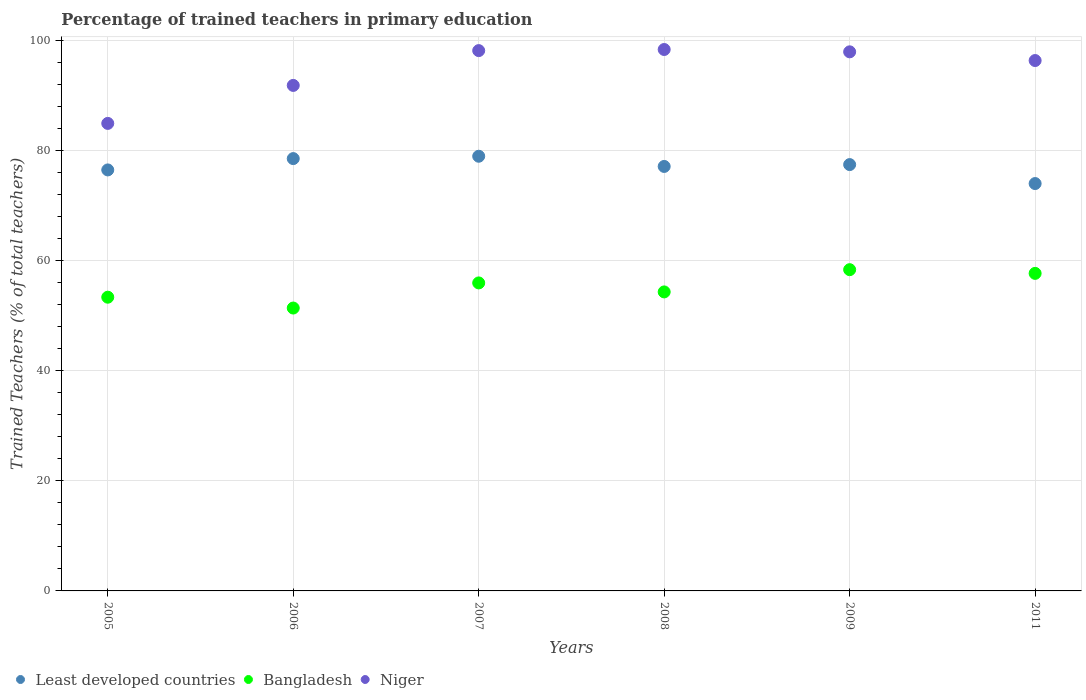Is the number of dotlines equal to the number of legend labels?
Give a very brief answer. Yes. What is the percentage of trained teachers in Bangladesh in 2006?
Provide a succinct answer. 51.43. Across all years, what is the maximum percentage of trained teachers in Bangladesh?
Your answer should be very brief. 58.41. Across all years, what is the minimum percentage of trained teachers in Least developed countries?
Provide a short and direct response. 74.06. In which year was the percentage of trained teachers in Least developed countries minimum?
Give a very brief answer. 2011. What is the total percentage of trained teachers in Bangladesh in the graph?
Your response must be concise. 331.34. What is the difference between the percentage of trained teachers in Niger in 2007 and that in 2009?
Provide a succinct answer. 0.22. What is the difference between the percentage of trained teachers in Bangladesh in 2005 and the percentage of trained teachers in Niger in 2009?
Your response must be concise. -44.61. What is the average percentage of trained teachers in Niger per year?
Your answer should be compact. 94.67. In the year 2006, what is the difference between the percentage of trained teachers in Niger and percentage of trained teachers in Bangladesh?
Provide a short and direct response. 40.48. In how many years, is the percentage of trained teachers in Niger greater than 68 %?
Give a very brief answer. 6. What is the ratio of the percentage of trained teachers in Niger in 2005 to that in 2006?
Give a very brief answer. 0.92. Is the percentage of trained teachers in Least developed countries in 2006 less than that in 2007?
Offer a terse response. Yes. Is the difference between the percentage of trained teachers in Niger in 2009 and 2011 greater than the difference between the percentage of trained teachers in Bangladesh in 2009 and 2011?
Provide a succinct answer. Yes. What is the difference between the highest and the second highest percentage of trained teachers in Niger?
Give a very brief answer. 0.2. What is the difference between the highest and the lowest percentage of trained teachers in Bangladesh?
Provide a short and direct response. 6.98. In how many years, is the percentage of trained teachers in Bangladesh greater than the average percentage of trained teachers in Bangladesh taken over all years?
Ensure brevity in your answer.  3. Is the percentage of trained teachers in Niger strictly less than the percentage of trained teachers in Least developed countries over the years?
Your answer should be compact. No. Are the values on the major ticks of Y-axis written in scientific E-notation?
Give a very brief answer. No. Does the graph contain any zero values?
Your answer should be very brief. No. Where does the legend appear in the graph?
Ensure brevity in your answer.  Bottom left. What is the title of the graph?
Your answer should be very brief. Percentage of trained teachers in primary education. Does "Belarus" appear as one of the legend labels in the graph?
Provide a succinct answer. No. What is the label or title of the Y-axis?
Provide a short and direct response. Trained Teachers (% of total teachers). What is the Trained Teachers (% of total teachers) in Least developed countries in 2005?
Offer a terse response. 76.54. What is the Trained Teachers (% of total teachers) in Bangladesh in 2005?
Keep it short and to the point. 53.4. What is the Trained Teachers (% of total teachers) of Niger in 2005?
Give a very brief answer. 85. What is the Trained Teachers (% of total teachers) in Least developed countries in 2006?
Keep it short and to the point. 78.6. What is the Trained Teachers (% of total teachers) of Bangladesh in 2006?
Keep it short and to the point. 51.43. What is the Trained Teachers (% of total teachers) in Niger in 2006?
Ensure brevity in your answer.  91.91. What is the Trained Teachers (% of total teachers) in Least developed countries in 2007?
Ensure brevity in your answer.  79.03. What is the Trained Teachers (% of total teachers) in Bangladesh in 2007?
Give a very brief answer. 56. What is the Trained Teachers (% of total teachers) in Niger in 2007?
Provide a succinct answer. 98.24. What is the Trained Teachers (% of total teachers) in Least developed countries in 2008?
Ensure brevity in your answer.  77.18. What is the Trained Teachers (% of total teachers) in Bangladesh in 2008?
Your answer should be very brief. 54.36. What is the Trained Teachers (% of total teachers) of Niger in 2008?
Ensure brevity in your answer.  98.44. What is the Trained Teachers (% of total teachers) of Least developed countries in 2009?
Offer a very short reply. 77.51. What is the Trained Teachers (% of total teachers) of Bangladesh in 2009?
Make the answer very short. 58.41. What is the Trained Teachers (% of total teachers) of Niger in 2009?
Give a very brief answer. 98.01. What is the Trained Teachers (% of total teachers) in Least developed countries in 2011?
Your answer should be very brief. 74.06. What is the Trained Teachers (% of total teachers) in Bangladesh in 2011?
Provide a short and direct response. 57.73. What is the Trained Teachers (% of total teachers) of Niger in 2011?
Your answer should be very brief. 96.43. Across all years, what is the maximum Trained Teachers (% of total teachers) of Least developed countries?
Your answer should be very brief. 79.03. Across all years, what is the maximum Trained Teachers (% of total teachers) in Bangladesh?
Offer a terse response. 58.41. Across all years, what is the maximum Trained Teachers (% of total teachers) in Niger?
Keep it short and to the point. 98.44. Across all years, what is the minimum Trained Teachers (% of total teachers) of Least developed countries?
Give a very brief answer. 74.06. Across all years, what is the minimum Trained Teachers (% of total teachers) in Bangladesh?
Your response must be concise. 51.43. Across all years, what is the minimum Trained Teachers (% of total teachers) in Niger?
Give a very brief answer. 85. What is the total Trained Teachers (% of total teachers) of Least developed countries in the graph?
Give a very brief answer. 462.93. What is the total Trained Teachers (% of total teachers) in Bangladesh in the graph?
Give a very brief answer. 331.34. What is the total Trained Teachers (% of total teachers) of Niger in the graph?
Offer a very short reply. 568.03. What is the difference between the Trained Teachers (% of total teachers) of Least developed countries in 2005 and that in 2006?
Offer a terse response. -2.06. What is the difference between the Trained Teachers (% of total teachers) in Bangladesh in 2005 and that in 2006?
Ensure brevity in your answer.  1.97. What is the difference between the Trained Teachers (% of total teachers) in Niger in 2005 and that in 2006?
Offer a very short reply. -6.91. What is the difference between the Trained Teachers (% of total teachers) in Least developed countries in 2005 and that in 2007?
Your response must be concise. -2.49. What is the difference between the Trained Teachers (% of total teachers) of Bangladesh in 2005 and that in 2007?
Ensure brevity in your answer.  -2.6. What is the difference between the Trained Teachers (% of total teachers) of Niger in 2005 and that in 2007?
Make the answer very short. -13.24. What is the difference between the Trained Teachers (% of total teachers) in Least developed countries in 2005 and that in 2008?
Ensure brevity in your answer.  -0.63. What is the difference between the Trained Teachers (% of total teachers) of Bangladesh in 2005 and that in 2008?
Give a very brief answer. -0.96. What is the difference between the Trained Teachers (% of total teachers) of Niger in 2005 and that in 2008?
Provide a short and direct response. -13.44. What is the difference between the Trained Teachers (% of total teachers) in Least developed countries in 2005 and that in 2009?
Your answer should be compact. -0.97. What is the difference between the Trained Teachers (% of total teachers) in Bangladesh in 2005 and that in 2009?
Offer a terse response. -5.01. What is the difference between the Trained Teachers (% of total teachers) in Niger in 2005 and that in 2009?
Your answer should be very brief. -13.01. What is the difference between the Trained Teachers (% of total teachers) in Least developed countries in 2005 and that in 2011?
Ensure brevity in your answer.  2.48. What is the difference between the Trained Teachers (% of total teachers) in Bangladesh in 2005 and that in 2011?
Your response must be concise. -4.33. What is the difference between the Trained Teachers (% of total teachers) of Niger in 2005 and that in 2011?
Offer a terse response. -11.43. What is the difference between the Trained Teachers (% of total teachers) in Least developed countries in 2006 and that in 2007?
Offer a terse response. -0.43. What is the difference between the Trained Teachers (% of total teachers) of Bangladesh in 2006 and that in 2007?
Provide a short and direct response. -4.57. What is the difference between the Trained Teachers (% of total teachers) in Niger in 2006 and that in 2007?
Offer a terse response. -6.33. What is the difference between the Trained Teachers (% of total teachers) in Least developed countries in 2006 and that in 2008?
Make the answer very short. 1.43. What is the difference between the Trained Teachers (% of total teachers) of Bangladesh in 2006 and that in 2008?
Ensure brevity in your answer.  -2.93. What is the difference between the Trained Teachers (% of total teachers) in Niger in 2006 and that in 2008?
Make the answer very short. -6.53. What is the difference between the Trained Teachers (% of total teachers) of Least developed countries in 2006 and that in 2009?
Offer a very short reply. 1.09. What is the difference between the Trained Teachers (% of total teachers) in Bangladesh in 2006 and that in 2009?
Provide a succinct answer. -6.98. What is the difference between the Trained Teachers (% of total teachers) of Niger in 2006 and that in 2009?
Give a very brief answer. -6.11. What is the difference between the Trained Teachers (% of total teachers) in Least developed countries in 2006 and that in 2011?
Ensure brevity in your answer.  4.54. What is the difference between the Trained Teachers (% of total teachers) of Bangladesh in 2006 and that in 2011?
Provide a succinct answer. -6.3. What is the difference between the Trained Teachers (% of total teachers) of Niger in 2006 and that in 2011?
Offer a terse response. -4.52. What is the difference between the Trained Teachers (% of total teachers) in Least developed countries in 2007 and that in 2008?
Give a very brief answer. 1.85. What is the difference between the Trained Teachers (% of total teachers) of Bangladesh in 2007 and that in 2008?
Keep it short and to the point. 1.64. What is the difference between the Trained Teachers (% of total teachers) of Niger in 2007 and that in 2008?
Provide a short and direct response. -0.2. What is the difference between the Trained Teachers (% of total teachers) of Least developed countries in 2007 and that in 2009?
Give a very brief answer. 1.52. What is the difference between the Trained Teachers (% of total teachers) of Bangladesh in 2007 and that in 2009?
Make the answer very short. -2.41. What is the difference between the Trained Teachers (% of total teachers) of Niger in 2007 and that in 2009?
Your answer should be very brief. 0.22. What is the difference between the Trained Teachers (% of total teachers) of Least developed countries in 2007 and that in 2011?
Provide a short and direct response. 4.97. What is the difference between the Trained Teachers (% of total teachers) in Bangladesh in 2007 and that in 2011?
Offer a very short reply. -1.74. What is the difference between the Trained Teachers (% of total teachers) of Niger in 2007 and that in 2011?
Your response must be concise. 1.81. What is the difference between the Trained Teachers (% of total teachers) in Least developed countries in 2008 and that in 2009?
Provide a short and direct response. -0.34. What is the difference between the Trained Teachers (% of total teachers) in Bangladesh in 2008 and that in 2009?
Provide a short and direct response. -4.04. What is the difference between the Trained Teachers (% of total teachers) in Niger in 2008 and that in 2009?
Provide a short and direct response. 0.42. What is the difference between the Trained Teachers (% of total teachers) of Least developed countries in 2008 and that in 2011?
Ensure brevity in your answer.  3.11. What is the difference between the Trained Teachers (% of total teachers) of Bangladesh in 2008 and that in 2011?
Make the answer very short. -3.37. What is the difference between the Trained Teachers (% of total teachers) of Niger in 2008 and that in 2011?
Your answer should be compact. 2.01. What is the difference between the Trained Teachers (% of total teachers) in Least developed countries in 2009 and that in 2011?
Ensure brevity in your answer.  3.45. What is the difference between the Trained Teachers (% of total teachers) in Bangladesh in 2009 and that in 2011?
Your response must be concise. 0.67. What is the difference between the Trained Teachers (% of total teachers) in Niger in 2009 and that in 2011?
Provide a succinct answer. 1.58. What is the difference between the Trained Teachers (% of total teachers) of Least developed countries in 2005 and the Trained Teachers (% of total teachers) of Bangladesh in 2006?
Provide a succinct answer. 25.11. What is the difference between the Trained Teachers (% of total teachers) in Least developed countries in 2005 and the Trained Teachers (% of total teachers) in Niger in 2006?
Provide a short and direct response. -15.36. What is the difference between the Trained Teachers (% of total teachers) of Bangladesh in 2005 and the Trained Teachers (% of total teachers) of Niger in 2006?
Offer a terse response. -38.51. What is the difference between the Trained Teachers (% of total teachers) in Least developed countries in 2005 and the Trained Teachers (% of total teachers) in Bangladesh in 2007?
Offer a terse response. 20.54. What is the difference between the Trained Teachers (% of total teachers) in Least developed countries in 2005 and the Trained Teachers (% of total teachers) in Niger in 2007?
Offer a terse response. -21.69. What is the difference between the Trained Teachers (% of total teachers) in Bangladesh in 2005 and the Trained Teachers (% of total teachers) in Niger in 2007?
Your response must be concise. -44.83. What is the difference between the Trained Teachers (% of total teachers) in Least developed countries in 2005 and the Trained Teachers (% of total teachers) in Bangladesh in 2008?
Make the answer very short. 22.18. What is the difference between the Trained Teachers (% of total teachers) in Least developed countries in 2005 and the Trained Teachers (% of total teachers) in Niger in 2008?
Keep it short and to the point. -21.89. What is the difference between the Trained Teachers (% of total teachers) of Bangladesh in 2005 and the Trained Teachers (% of total teachers) of Niger in 2008?
Provide a short and direct response. -45.04. What is the difference between the Trained Teachers (% of total teachers) of Least developed countries in 2005 and the Trained Teachers (% of total teachers) of Bangladesh in 2009?
Make the answer very short. 18.14. What is the difference between the Trained Teachers (% of total teachers) of Least developed countries in 2005 and the Trained Teachers (% of total teachers) of Niger in 2009?
Offer a terse response. -21.47. What is the difference between the Trained Teachers (% of total teachers) in Bangladesh in 2005 and the Trained Teachers (% of total teachers) in Niger in 2009?
Ensure brevity in your answer.  -44.61. What is the difference between the Trained Teachers (% of total teachers) in Least developed countries in 2005 and the Trained Teachers (% of total teachers) in Bangladesh in 2011?
Provide a short and direct response. 18.81. What is the difference between the Trained Teachers (% of total teachers) of Least developed countries in 2005 and the Trained Teachers (% of total teachers) of Niger in 2011?
Give a very brief answer. -19.89. What is the difference between the Trained Teachers (% of total teachers) in Bangladesh in 2005 and the Trained Teachers (% of total teachers) in Niger in 2011?
Make the answer very short. -43.03. What is the difference between the Trained Teachers (% of total teachers) of Least developed countries in 2006 and the Trained Teachers (% of total teachers) of Bangladesh in 2007?
Make the answer very short. 22.6. What is the difference between the Trained Teachers (% of total teachers) of Least developed countries in 2006 and the Trained Teachers (% of total teachers) of Niger in 2007?
Your response must be concise. -19.63. What is the difference between the Trained Teachers (% of total teachers) of Bangladesh in 2006 and the Trained Teachers (% of total teachers) of Niger in 2007?
Make the answer very short. -46.8. What is the difference between the Trained Teachers (% of total teachers) of Least developed countries in 2006 and the Trained Teachers (% of total teachers) of Bangladesh in 2008?
Make the answer very short. 24.24. What is the difference between the Trained Teachers (% of total teachers) of Least developed countries in 2006 and the Trained Teachers (% of total teachers) of Niger in 2008?
Give a very brief answer. -19.83. What is the difference between the Trained Teachers (% of total teachers) of Bangladesh in 2006 and the Trained Teachers (% of total teachers) of Niger in 2008?
Offer a terse response. -47.01. What is the difference between the Trained Teachers (% of total teachers) of Least developed countries in 2006 and the Trained Teachers (% of total teachers) of Bangladesh in 2009?
Make the answer very short. 20.2. What is the difference between the Trained Teachers (% of total teachers) in Least developed countries in 2006 and the Trained Teachers (% of total teachers) in Niger in 2009?
Ensure brevity in your answer.  -19.41. What is the difference between the Trained Teachers (% of total teachers) in Bangladesh in 2006 and the Trained Teachers (% of total teachers) in Niger in 2009?
Provide a short and direct response. -46.58. What is the difference between the Trained Teachers (% of total teachers) in Least developed countries in 2006 and the Trained Teachers (% of total teachers) in Bangladesh in 2011?
Offer a very short reply. 20.87. What is the difference between the Trained Teachers (% of total teachers) in Least developed countries in 2006 and the Trained Teachers (% of total teachers) in Niger in 2011?
Give a very brief answer. -17.83. What is the difference between the Trained Teachers (% of total teachers) in Bangladesh in 2006 and the Trained Teachers (% of total teachers) in Niger in 2011?
Ensure brevity in your answer.  -45. What is the difference between the Trained Teachers (% of total teachers) of Least developed countries in 2007 and the Trained Teachers (% of total teachers) of Bangladesh in 2008?
Make the answer very short. 24.67. What is the difference between the Trained Teachers (% of total teachers) of Least developed countries in 2007 and the Trained Teachers (% of total teachers) of Niger in 2008?
Make the answer very short. -19.41. What is the difference between the Trained Teachers (% of total teachers) of Bangladesh in 2007 and the Trained Teachers (% of total teachers) of Niger in 2008?
Give a very brief answer. -42.44. What is the difference between the Trained Teachers (% of total teachers) of Least developed countries in 2007 and the Trained Teachers (% of total teachers) of Bangladesh in 2009?
Give a very brief answer. 20.62. What is the difference between the Trained Teachers (% of total teachers) in Least developed countries in 2007 and the Trained Teachers (% of total teachers) in Niger in 2009?
Your response must be concise. -18.98. What is the difference between the Trained Teachers (% of total teachers) in Bangladesh in 2007 and the Trained Teachers (% of total teachers) in Niger in 2009?
Provide a short and direct response. -42.01. What is the difference between the Trained Teachers (% of total teachers) in Least developed countries in 2007 and the Trained Teachers (% of total teachers) in Bangladesh in 2011?
Provide a short and direct response. 21.3. What is the difference between the Trained Teachers (% of total teachers) in Least developed countries in 2007 and the Trained Teachers (% of total teachers) in Niger in 2011?
Your answer should be compact. -17.4. What is the difference between the Trained Teachers (% of total teachers) of Bangladesh in 2007 and the Trained Teachers (% of total teachers) of Niger in 2011?
Your response must be concise. -40.43. What is the difference between the Trained Teachers (% of total teachers) in Least developed countries in 2008 and the Trained Teachers (% of total teachers) in Bangladesh in 2009?
Ensure brevity in your answer.  18.77. What is the difference between the Trained Teachers (% of total teachers) of Least developed countries in 2008 and the Trained Teachers (% of total teachers) of Niger in 2009?
Your response must be concise. -20.84. What is the difference between the Trained Teachers (% of total teachers) in Bangladesh in 2008 and the Trained Teachers (% of total teachers) in Niger in 2009?
Keep it short and to the point. -43.65. What is the difference between the Trained Teachers (% of total teachers) in Least developed countries in 2008 and the Trained Teachers (% of total teachers) in Bangladesh in 2011?
Your response must be concise. 19.44. What is the difference between the Trained Teachers (% of total teachers) in Least developed countries in 2008 and the Trained Teachers (% of total teachers) in Niger in 2011?
Your response must be concise. -19.25. What is the difference between the Trained Teachers (% of total teachers) in Bangladesh in 2008 and the Trained Teachers (% of total teachers) in Niger in 2011?
Your answer should be compact. -42.07. What is the difference between the Trained Teachers (% of total teachers) of Least developed countries in 2009 and the Trained Teachers (% of total teachers) of Bangladesh in 2011?
Offer a terse response. 19.78. What is the difference between the Trained Teachers (% of total teachers) of Least developed countries in 2009 and the Trained Teachers (% of total teachers) of Niger in 2011?
Your answer should be compact. -18.92. What is the difference between the Trained Teachers (% of total teachers) of Bangladesh in 2009 and the Trained Teachers (% of total teachers) of Niger in 2011?
Make the answer very short. -38.02. What is the average Trained Teachers (% of total teachers) in Least developed countries per year?
Ensure brevity in your answer.  77.16. What is the average Trained Teachers (% of total teachers) in Bangladesh per year?
Offer a terse response. 55.22. What is the average Trained Teachers (% of total teachers) in Niger per year?
Provide a short and direct response. 94.67. In the year 2005, what is the difference between the Trained Teachers (% of total teachers) of Least developed countries and Trained Teachers (% of total teachers) of Bangladesh?
Offer a very short reply. 23.14. In the year 2005, what is the difference between the Trained Teachers (% of total teachers) in Least developed countries and Trained Teachers (% of total teachers) in Niger?
Your answer should be compact. -8.46. In the year 2005, what is the difference between the Trained Teachers (% of total teachers) in Bangladesh and Trained Teachers (% of total teachers) in Niger?
Offer a terse response. -31.6. In the year 2006, what is the difference between the Trained Teachers (% of total teachers) in Least developed countries and Trained Teachers (% of total teachers) in Bangladesh?
Keep it short and to the point. 27.17. In the year 2006, what is the difference between the Trained Teachers (% of total teachers) of Least developed countries and Trained Teachers (% of total teachers) of Niger?
Make the answer very short. -13.3. In the year 2006, what is the difference between the Trained Teachers (% of total teachers) in Bangladesh and Trained Teachers (% of total teachers) in Niger?
Make the answer very short. -40.48. In the year 2007, what is the difference between the Trained Teachers (% of total teachers) of Least developed countries and Trained Teachers (% of total teachers) of Bangladesh?
Give a very brief answer. 23.03. In the year 2007, what is the difference between the Trained Teachers (% of total teachers) of Least developed countries and Trained Teachers (% of total teachers) of Niger?
Your answer should be very brief. -19.21. In the year 2007, what is the difference between the Trained Teachers (% of total teachers) of Bangladesh and Trained Teachers (% of total teachers) of Niger?
Offer a very short reply. -42.24. In the year 2008, what is the difference between the Trained Teachers (% of total teachers) of Least developed countries and Trained Teachers (% of total teachers) of Bangladesh?
Make the answer very short. 22.81. In the year 2008, what is the difference between the Trained Teachers (% of total teachers) of Least developed countries and Trained Teachers (% of total teachers) of Niger?
Provide a succinct answer. -21.26. In the year 2008, what is the difference between the Trained Teachers (% of total teachers) in Bangladesh and Trained Teachers (% of total teachers) in Niger?
Keep it short and to the point. -44.07. In the year 2009, what is the difference between the Trained Teachers (% of total teachers) of Least developed countries and Trained Teachers (% of total teachers) of Bangladesh?
Offer a very short reply. 19.11. In the year 2009, what is the difference between the Trained Teachers (% of total teachers) of Least developed countries and Trained Teachers (% of total teachers) of Niger?
Ensure brevity in your answer.  -20.5. In the year 2009, what is the difference between the Trained Teachers (% of total teachers) in Bangladesh and Trained Teachers (% of total teachers) in Niger?
Your answer should be compact. -39.61. In the year 2011, what is the difference between the Trained Teachers (% of total teachers) in Least developed countries and Trained Teachers (% of total teachers) in Bangladesh?
Make the answer very short. 16.33. In the year 2011, what is the difference between the Trained Teachers (% of total teachers) of Least developed countries and Trained Teachers (% of total teachers) of Niger?
Keep it short and to the point. -22.37. In the year 2011, what is the difference between the Trained Teachers (% of total teachers) of Bangladesh and Trained Teachers (% of total teachers) of Niger?
Provide a short and direct response. -38.7. What is the ratio of the Trained Teachers (% of total teachers) in Least developed countries in 2005 to that in 2006?
Offer a terse response. 0.97. What is the ratio of the Trained Teachers (% of total teachers) in Bangladesh in 2005 to that in 2006?
Provide a succinct answer. 1.04. What is the ratio of the Trained Teachers (% of total teachers) of Niger in 2005 to that in 2006?
Your response must be concise. 0.92. What is the ratio of the Trained Teachers (% of total teachers) of Least developed countries in 2005 to that in 2007?
Make the answer very short. 0.97. What is the ratio of the Trained Teachers (% of total teachers) in Bangladesh in 2005 to that in 2007?
Keep it short and to the point. 0.95. What is the ratio of the Trained Teachers (% of total teachers) in Niger in 2005 to that in 2007?
Offer a very short reply. 0.87. What is the ratio of the Trained Teachers (% of total teachers) in Least developed countries in 2005 to that in 2008?
Provide a succinct answer. 0.99. What is the ratio of the Trained Teachers (% of total teachers) in Bangladesh in 2005 to that in 2008?
Your answer should be very brief. 0.98. What is the ratio of the Trained Teachers (% of total teachers) in Niger in 2005 to that in 2008?
Ensure brevity in your answer.  0.86. What is the ratio of the Trained Teachers (% of total teachers) of Least developed countries in 2005 to that in 2009?
Offer a very short reply. 0.99. What is the ratio of the Trained Teachers (% of total teachers) in Bangladesh in 2005 to that in 2009?
Offer a very short reply. 0.91. What is the ratio of the Trained Teachers (% of total teachers) of Niger in 2005 to that in 2009?
Offer a very short reply. 0.87. What is the ratio of the Trained Teachers (% of total teachers) in Least developed countries in 2005 to that in 2011?
Your answer should be compact. 1.03. What is the ratio of the Trained Teachers (% of total teachers) of Bangladesh in 2005 to that in 2011?
Offer a very short reply. 0.93. What is the ratio of the Trained Teachers (% of total teachers) of Niger in 2005 to that in 2011?
Make the answer very short. 0.88. What is the ratio of the Trained Teachers (% of total teachers) of Least developed countries in 2006 to that in 2007?
Give a very brief answer. 0.99. What is the ratio of the Trained Teachers (% of total teachers) in Bangladesh in 2006 to that in 2007?
Your response must be concise. 0.92. What is the ratio of the Trained Teachers (% of total teachers) in Niger in 2006 to that in 2007?
Keep it short and to the point. 0.94. What is the ratio of the Trained Teachers (% of total teachers) of Least developed countries in 2006 to that in 2008?
Keep it short and to the point. 1.02. What is the ratio of the Trained Teachers (% of total teachers) in Bangladesh in 2006 to that in 2008?
Provide a short and direct response. 0.95. What is the ratio of the Trained Teachers (% of total teachers) of Niger in 2006 to that in 2008?
Provide a short and direct response. 0.93. What is the ratio of the Trained Teachers (% of total teachers) in Least developed countries in 2006 to that in 2009?
Provide a short and direct response. 1.01. What is the ratio of the Trained Teachers (% of total teachers) in Bangladesh in 2006 to that in 2009?
Provide a short and direct response. 0.88. What is the ratio of the Trained Teachers (% of total teachers) of Niger in 2006 to that in 2009?
Provide a succinct answer. 0.94. What is the ratio of the Trained Teachers (% of total teachers) in Least developed countries in 2006 to that in 2011?
Give a very brief answer. 1.06. What is the ratio of the Trained Teachers (% of total teachers) of Bangladesh in 2006 to that in 2011?
Keep it short and to the point. 0.89. What is the ratio of the Trained Teachers (% of total teachers) in Niger in 2006 to that in 2011?
Offer a very short reply. 0.95. What is the ratio of the Trained Teachers (% of total teachers) in Bangladesh in 2007 to that in 2008?
Keep it short and to the point. 1.03. What is the ratio of the Trained Teachers (% of total teachers) in Least developed countries in 2007 to that in 2009?
Give a very brief answer. 1.02. What is the ratio of the Trained Teachers (% of total teachers) of Bangladesh in 2007 to that in 2009?
Offer a very short reply. 0.96. What is the ratio of the Trained Teachers (% of total teachers) of Least developed countries in 2007 to that in 2011?
Offer a terse response. 1.07. What is the ratio of the Trained Teachers (% of total teachers) in Bangladesh in 2007 to that in 2011?
Give a very brief answer. 0.97. What is the ratio of the Trained Teachers (% of total teachers) in Niger in 2007 to that in 2011?
Give a very brief answer. 1.02. What is the ratio of the Trained Teachers (% of total teachers) in Bangladesh in 2008 to that in 2009?
Ensure brevity in your answer.  0.93. What is the ratio of the Trained Teachers (% of total teachers) in Least developed countries in 2008 to that in 2011?
Your response must be concise. 1.04. What is the ratio of the Trained Teachers (% of total teachers) of Bangladesh in 2008 to that in 2011?
Keep it short and to the point. 0.94. What is the ratio of the Trained Teachers (% of total teachers) in Niger in 2008 to that in 2011?
Give a very brief answer. 1.02. What is the ratio of the Trained Teachers (% of total teachers) of Least developed countries in 2009 to that in 2011?
Ensure brevity in your answer.  1.05. What is the ratio of the Trained Teachers (% of total teachers) in Bangladesh in 2009 to that in 2011?
Offer a terse response. 1.01. What is the ratio of the Trained Teachers (% of total teachers) of Niger in 2009 to that in 2011?
Provide a short and direct response. 1.02. What is the difference between the highest and the second highest Trained Teachers (% of total teachers) of Least developed countries?
Make the answer very short. 0.43. What is the difference between the highest and the second highest Trained Teachers (% of total teachers) in Bangladesh?
Keep it short and to the point. 0.67. What is the difference between the highest and the second highest Trained Teachers (% of total teachers) of Niger?
Your response must be concise. 0.2. What is the difference between the highest and the lowest Trained Teachers (% of total teachers) of Least developed countries?
Make the answer very short. 4.97. What is the difference between the highest and the lowest Trained Teachers (% of total teachers) in Bangladesh?
Offer a terse response. 6.98. What is the difference between the highest and the lowest Trained Teachers (% of total teachers) of Niger?
Make the answer very short. 13.44. 